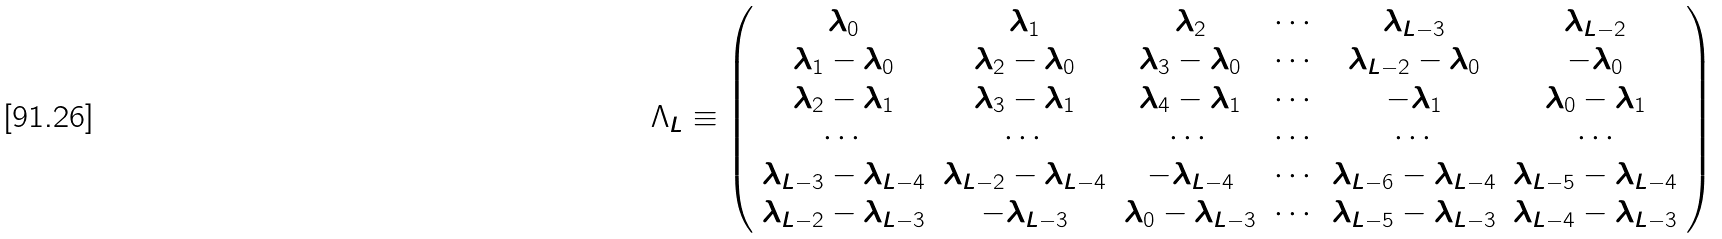Convert formula to latex. <formula><loc_0><loc_0><loc_500><loc_500>\Lambda _ { L } \equiv \left ( \begin{array} { c c c c c c } \lambda _ { 0 } & \lambda _ { 1 } & \lambda _ { 2 } & \cdots & \lambda _ { L - 3 } & \lambda _ { L - 2 } \\ \lambda _ { 1 } - \lambda _ { 0 } & \lambda _ { 2 } - \lambda _ { 0 } & \lambda _ { 3 } - \lambda _ { 0 } & \cdots & \lambda _ { L - 2 } - \lambda _ { 0 } & - \lambda _ { 0 } \\ \lambda _ { 2 } - \lambda _ { 1 } & \lambda _ { 3 } - \lambda _ { 1 } & \lambda _ { 4 } - \lambda _ { 1 } & \cdots & - \lambda _ { 1 } & \lambda _ { 0 } - \lambda _ { 1 } \\ \cdots & \cdots & \cdots & \cdots & \cdots & \cdots \\ \lambda _ { L - 3 } - \lambda _ { L - 4 } & \lambda _ { L - 2 } - \lambda _ { L - 4 } & - \lambda _ { L - 4 } & \cdots & \lambda _ { L - 6 } - \lambda _ { L - 4 } & \lambda _ { L - 5 } - \lambda _ { L - 4 } \\ \lambda _ { L - 2 } - \lambda _ { L - 3 } & - \lambda _ { L - 3 } & \lambda _ { 0 } - \lambda _ { L - 3 } & \cdots & \lambda _ { L - 5 } - \lambda _ { L - 3 } & \lambda _ { L - 4 } - \lambda _ { L - 3 } \\ \end{array} \right )</formula> 